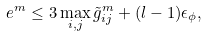<formula> <loc_0><loc_0><loc_500><loc_500>e ^ { m } \leq 3 \max _ { i , j } \tilde { g } ^ { m } _ { i j } + ( l - 1 ) \epsilon _ { \phi } ,</formula> 